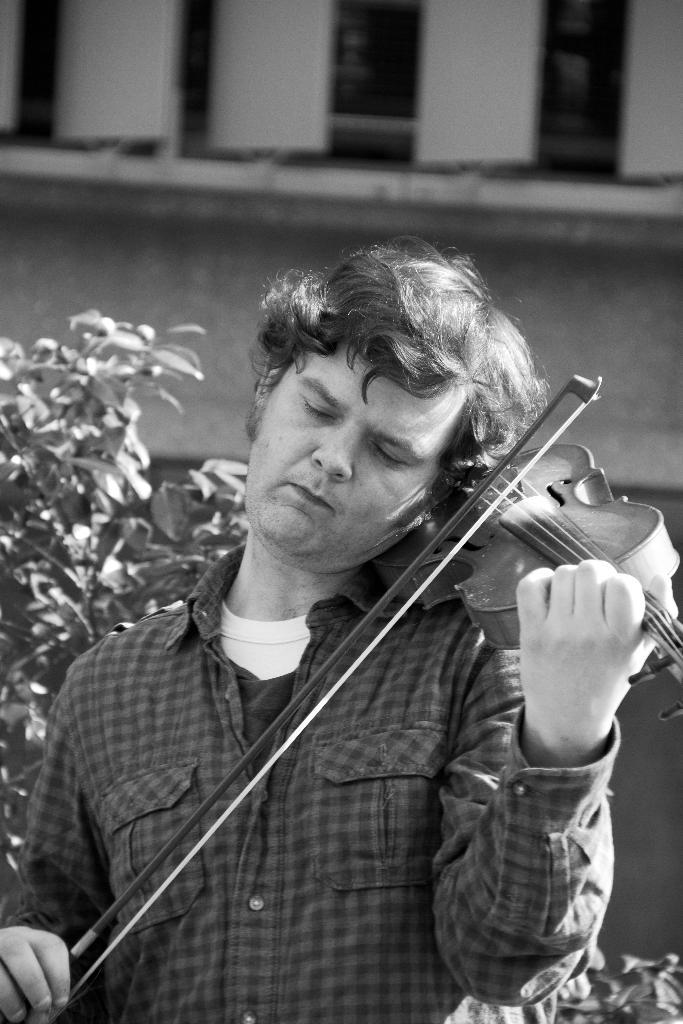What is the man in the image doing? The man is playing a violin. What can be seen in the background of the image? There is a tree and a building in the background of the image. Where is the downtown area in the image? There is no downtown area mentioned or visible in the image. 